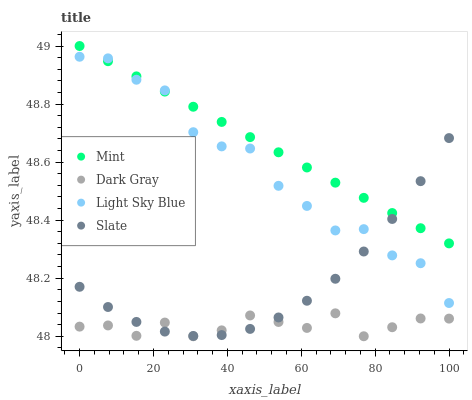Does Dark Gray have the minimum area under the curve?
Answer yes or no. Yes. Does Mint have the maximum area under the curve?
Answer yes or no. Yes. Does Slate have the minimum area under the curve?
Answer yes or no. No. Does Slate have the maximum area under the curve?
Answer yes or no. No. Is Mint the smoothest?
Answer yes or no. Yes. Is Light Sky Blue the roughest?
Answer yes or no. Yes. Is Slate the smoothest?
Answer yes or no. No. Is Slate the roughest?
Answer yes or no. No. Does Dark Gray have the lowest value?
Answer yes or no. Yes. Does Slate have the lowest value?
Answer yes or no. No. Does Mint have the highest value?
Answer yes or no. Yes. Does Slate have the highest value?
Answer yes or no. No. Is Dark Gray less than Mint?
Answer yes or no. Yes. Is Light Sky Blue greater than Dark Gray?
Answer yes or no. Yes. Does Slate intersect Dark Gray?
Answer yes or no. Yes. Is Slate less than Dark Gray?
Answer yes or no. No. Is Slate greater than Dark Gray?
Answer yes or no. No. Does Dark Gray intersect Mint?
Answer yes or no. No. 